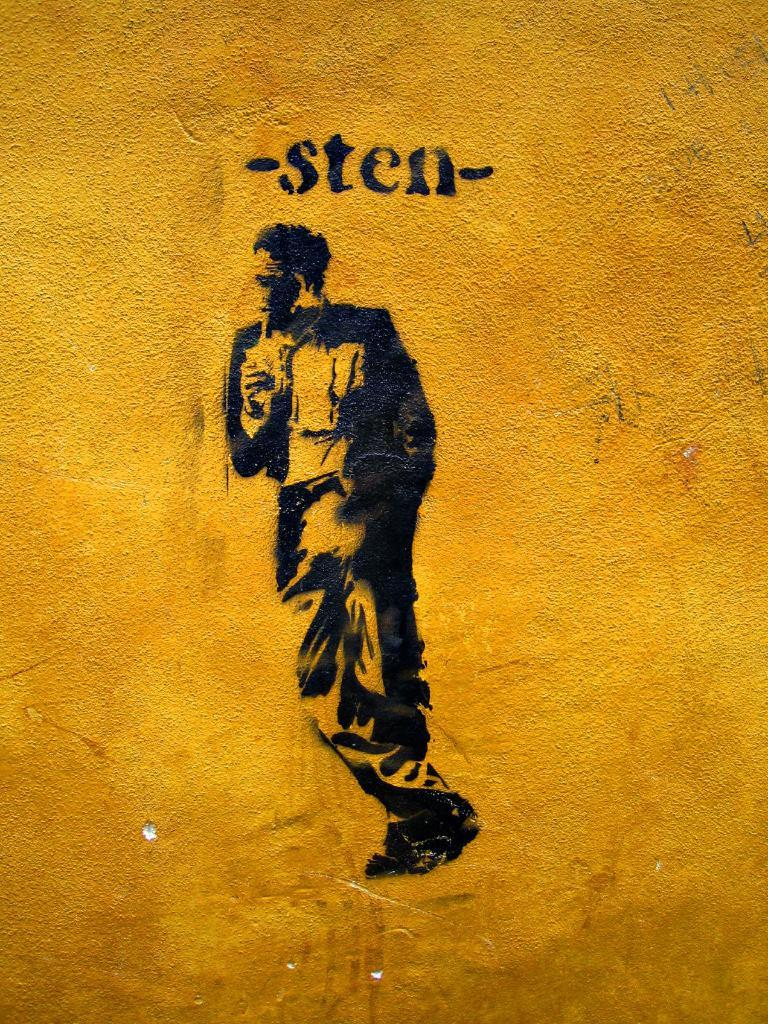Provide a one-sentence caption for the provided image. a man painted in black on a textured gold background with the writing -sten- above him. 